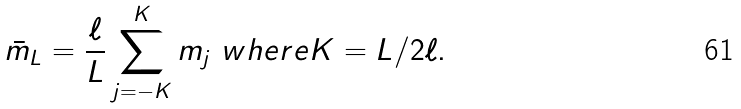Convert formula to latex. <formula><loc_0><loc_0><loc_500><loc_500>\bar { m } _ { L } = \frac { \ell } { L } \sum _ { j = - K } ^ { K } m _ { j } \ w h e r e K = L / 2 \ell .</formula> 